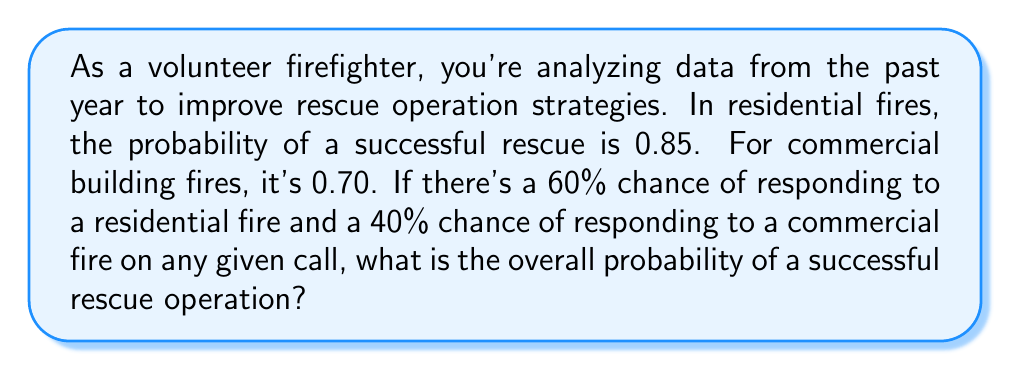Can you solve this math problem? Let's approach this step-by-step using the law of total probability:

1) Define events:
   R: Responding to a residential fire
   C: Responding to a commercial fire
   S: Successful rescue operation

2) Given probabilities:
   P(R) = 0.60
   P(C) = 0.40
   P(S|R) = 0.85 (probability of success given residential fire)
   P(S|C) = 0.70 (probability of success given commercial fire)

3) Use the law of total probability:
   $$P(S) = P(S|R) \cdot P(R) + P(S|C) \cdot P(C)$$

4) Substitute the values:
   $$P(S) = 0.85 \cdot 0.60 + 0.70 \cdot 0.40$$

5) Calculate:
   $$P(S) = 0.51 + 0.28 = 0.79$$

Thus, the overall probability of a successful rescue operation is 0.79 or 79%.
Answer: 0.79 or 79% 